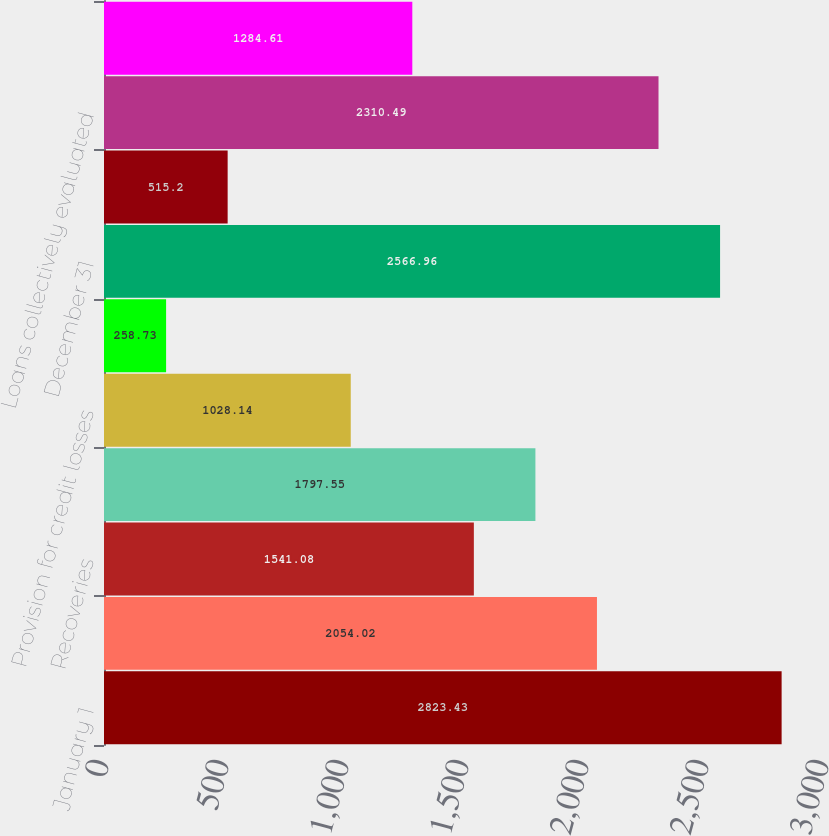Convert chart to OTSL. <chart><loc_0><loc_0><loc_500><loc_500><bar_chart><fcel>January 1<fcel>Charge-offs<fcel>Recoveries<fcel>Net charge-offs<fcel>Provision for credit losses<fcel>Net change in allowance for<fcel>December 31<fcel>TDRs individually evaluated<fcel>Loans collectively evaluated<fcel>Purchased impaired loans<nl><fcel>2823.43<fcel>2054.02<fcel>1541.08<fcel>1797.55<fcel>1028.14<fcel>258.73<fcel>2566.96<fcel>515.2<fcel>2310.49<fcel>1284.61<nl></chart> 